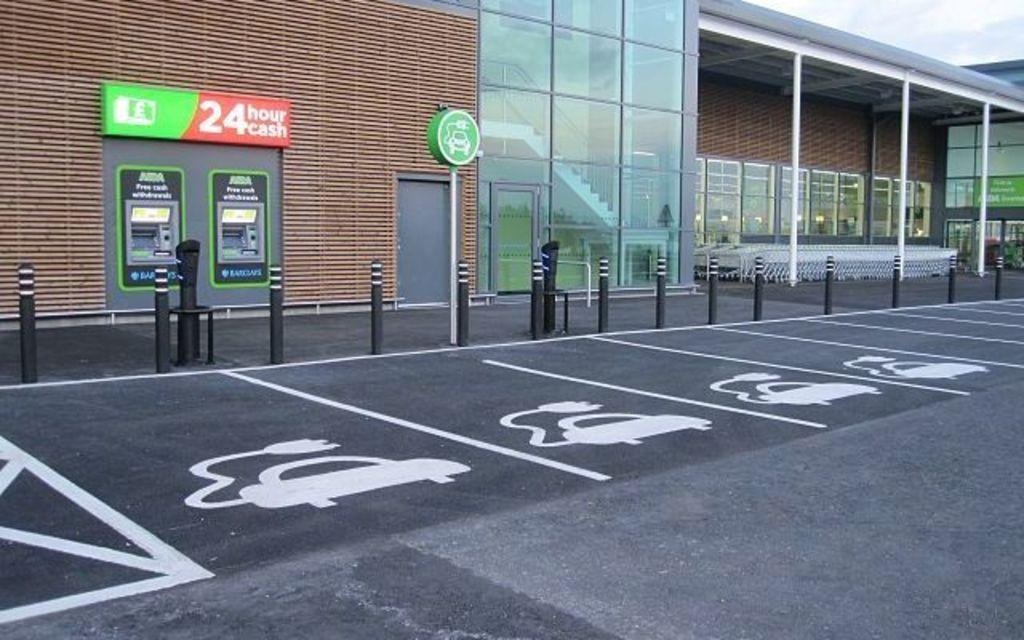What is in the foreground of the image? There is a road in the foreground of the image. What can be seen in the background of the image? In the background of the image, there are posters, poles, buildings, and the sky. Can you describe the objects in the background? The background features posters, poles, and buildings. The sky is also visible. How many hands are visible on the zebra in the image? There is no zebra present in the image, so there are no hands visible on a zebra. 